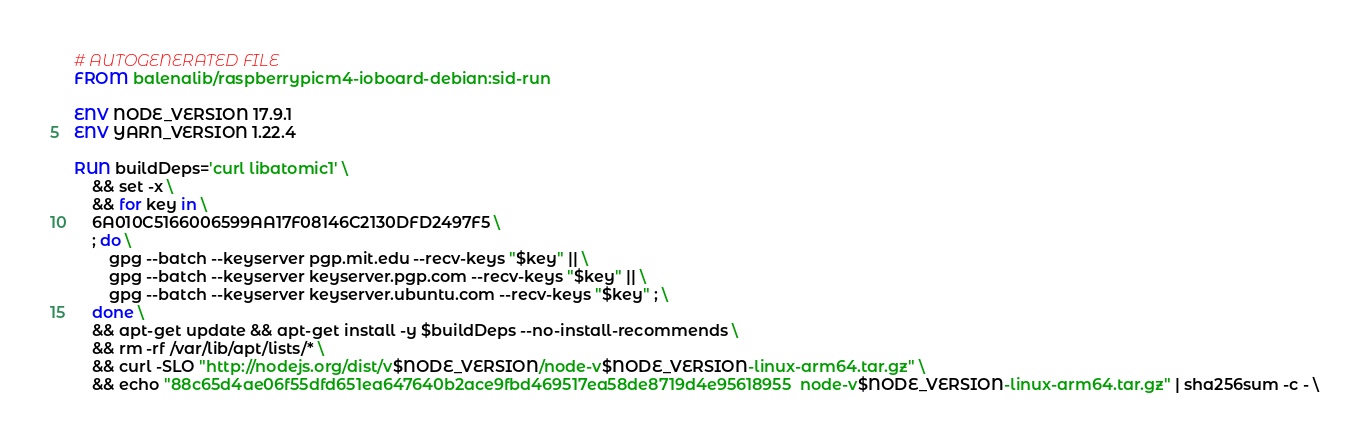<code> <loc_0><loc_0><loc_500><loc_500><_Dockerfile_># AUTOGENERATED FILE
FROM balenalib/raspberrypicm4-ioboard-debian:sid-run

ENV NODE_VERSION 17.9.1
ENV YARN_VERSION 1.22.4

RUN buildDeps='curl libatomic1' \
	&& set -x \
	&& for key in \
	6A010C5166006599AA17F08146C2130DFD2497F5 \
	; do \
		gpg --batch --keyserver pgp.mit.edu --recv-keys "$key" || \
		gpg --batch --keyserver keyserver.pgp.com --recv-keys "$key" || \
		gpg --batch --keyserver keyserver.ubuntu.com --recv-keys "$key" ; \
	done \
	&& apt-get update && apt-get install -y $buildDeps --no-install-recommends \
	&& rm -rf /var/lib/apt/lists/* \
	&& curl -SLO "http://nodejs.org/dist/v$NODE_VERSION/node-v$NODE_VERSION-linux-arm64.tar.gz" \
	&& echo "88c65d4ae06f55dfd651ea647640b2ace9fbd469517ea58de8719d4e95618955  node-v$NODE_VERSION-linux-arm64.tar.gz" | sha256sum -c - \</code> 